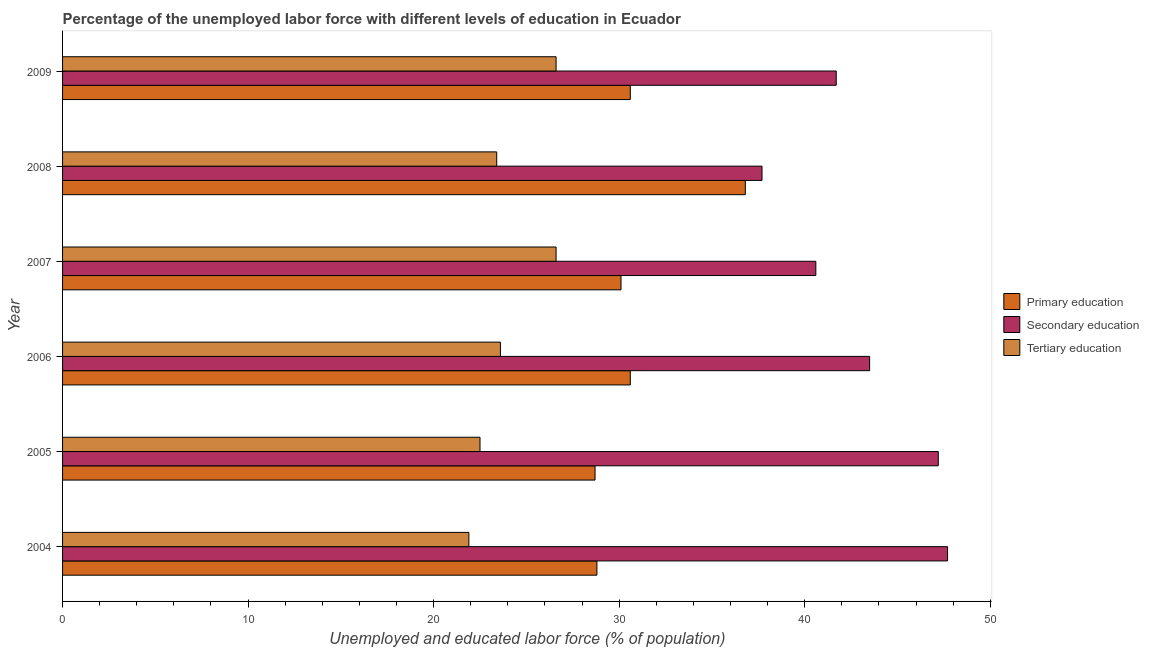Are the number of bars per tick equal to the number of legend labels?
Keep it short and to the point. Yes. Are the number of bars on each tick of the Y-axis equal?
Keep it short and to the point. Yes. How many bars are there on the 3rd tick from the bottom?
Provide a short and direct response. 3. In how many cases, is the number of bars for a given year not equal to the number of legend labels?
Give a very brief answer. 0. What is the percentage of labor force who received primary education in 2008?
Ensure brevity in your answer.  36.8. Across all years, what is the maximum percentage of labor force who received primary education?
Your answer should be very brief. 36.8. Across all years, what is the minimum percentage of labor force who received secondary education?
Offer a very short reply. 37.7. In which year was the percentage of labor force who received tertiary education maximum?
Keep it short and to the point. 2007. In which year was the percentage of labor force who received tertiary education minimum?
Keep it short and to the point. 2004. What is the total percentage of labor force who received secondary education in the graph?
Your response must be concise. 258.4. What is the difference between the percentage of labor force who received primary education in 2004 and the percentage of labor force who received tertiary education in 2008?
Provide a succinct answer. 5.4. What is the average percentage of labor force who received tertiary education per year?
Offer a very short reply. 24.1. In the year 2008, what is the difference between the percentage of labor force who received primary education and percentage of labor force who received secondary education?
Ensure brevity in your answer.  -0.9. In how many years, is the percentage of labor force who received tertiary education greater than 10 %?
Keep it short and to the point. 6. What is the ratio of the percentage of labor force who received tertiary education in 2006 to that in 2009?
Your response must be concise. 0.89. In how many years, is the percentage of labor force who received primary education greater than the average percentage of labor force who received primary education taken over all years?
Your answer should be compact. 1. What does the 1st bar from the top in 2008 represents?
Provide a succinct answer. Tertiary education. What does the 2nd bar from the bottom in 2009 represents?
Give a very brief answer. Secondary education. Is it the case that in every year, the sum of the percentage of labor force who received primary education and percentage of labor force who received secondary education is greater than the percentage of labor force who received tertiary education?
Provide a succinct answer. Yes. How many years are there in the graph?
Your answer should be very brief. 6. What is the difference between two consecutive major ticks on the X-axis?
Give a very brief answer. 10. Are the values on the major ticks of X-axis written in scientific E-notation?
Make the answer very short. No. Does the graph contain any zero values?
Offer a terse response. No. Does the graph contain grids?
Give a very brief answer. No. How many legend labels are there?
Provide a short and direct response. 3. What is the title of the graph?
Your response must be concise. Percentage of the unemployed labor force with different levels of education in Ecuador. What is the label or title of the X-axis?
Ensure brevity in your answer.  Unemployed and educated labor force (% of population). What is the Unemployed and educated labor force (% of population) of Primary education in 2004?
Give a very brief answer. 28.8. What is the Unemployed and educated labor force (% of population) of Secondary education in 2004?
Your response must be concise. 47.7. What is the Unemployed and educated labor force (% of population) of Tertiary education in 2004?
Give a very brief answer. 21.9. What is the Unemployed and educated labor force (% of population) of Primary education in 2005?
Provide a short and direct response. 28.7. What is the Unemployed and educated labor force (% of population) in Secondary education in 2005?
Your response must be concise. 47.2. What is the Unemployed and educated labor force (% of population) in Primary education in 2006?
Your answer should be very brief. 30.6. What is the Unemployed and educated labor force (% of population) of Secondary education in 2006?
Ensure brevity in your answer.  43.5. What is the Unemployed and educated labor force (% of population) of Tertiary education in 2006?
Give a very brief answer. 23.6. What is the Unemployed and educated labor force (% of population) of Primary education in 2007?
Provide a short and direct response. 30.1. What is the Unemployed and educated labor force (% of population) of Secondary education in 2007?
Offer a terse response. 40.6. What is the Unemployed and educated labor force (% of population) in Tertiary education in 2007?
Your answer should be compact. 26.6. What is the Unemployed and educated labor force (% of population) in Primary education in 2008?
Keep it short and to the point. 36.8. What is the Unemployed and educated labor force (% of population) in Secondary education in 2008?
Ensure brevity in your answer.  37.7. What is the Unemployed and educated labor force (% of population) of Tertiary education in 2008?
Provide a short and direct response. 23.4. What is the Unemployed and educated labor force (% of population) in Primary education in 2009?
Offer a terse response. 30.6. What is the Unemployed and educated labor force (% of population) in Secondary education in 2009?
Give a very brief answer. 41.7. What is the Unemployed and educated labor force (% of population) of Tertiary education in 2009?
Make the answer very short. 26.6. Across all years, what is the maximum Unemployed and educated labor force (% of population) in Primary education?
Provide a succinct answer. 36.8. Across all years, what is the maximum Unemployed and educated labor force (% of population) of Secondary education?
Your answer should be compact. 47.7. Across all years, what is the maximum Unemployed and educated labor force (% of population) in Tertiary education?
Ensure brevity in your answer.  26.6. Across all years, what is the minimum Unemployed and educated labor force (% of population) in Primary education?
Your answer should be compact. 28.7. Across all years, what is the minimum Unemployed and educated labor force (% of population) of Secondary education?
Your response must be concise. 37.7. Across all years, what is the minimum Unemployed and educated labor force (% of population) of Tertiary education?
Your answer should be compact. 21.9. What is the total Unemployed and educated labor force (% of population) in Primary education in the graph?
Your answer should be very brief. 185.6. What is the total Unemployed and educated labor force (% of population) of Secondary education in the graph?
Ensure brevity in your answer.  258.4. What is the total Unemployed and educated labor force (% of population) in Tertiary education in the graph?
Your response must be concise. 144.6. What is the difference between the Unemployed and educated labor force (% of population) in Primary education in 2004 and that in 2005?
Provide a succinct answer. 0.1. What is the difference between the Unemployed and educated labor force (% of population) in Secondary education in 2004 and that in 2005?
Provide a succinct answer. 0.5. What is the difference between the Unemployed and educated labor force (% of population) of Secondary education in 2004 and that in 2006?
Keep it short and to the point. 4.2. What is the difference between the Unemployed and educated labor force (% of population) in Tertiary education in 2004 and that in 2006?
Your response must be concise. -1.7. What is the difference between the Unemployed and educated labor force (% of population) of Secondary education in 2004 and that in 2007?
Provide a short and direct response. 7.1. What is the difference between the Unemployed and educated labor force (% of population) in Secondary education in 2004 and that in 2008?
Offer a very short reply. 10. What is the difference between the Unemployed and educated labor force (% of population) in Tertiary education in 2004 and that in 2008?
Ensure brevity in your answer.  -1.5. What is the difference between the Unemployed and educated labor force (% of population) of Primary education in 2004 and that in 2009?
Your answer should be very brief. -1.8. What is the difference between the Unemployed and educated labor force (% of population) of Secondary education in 2004 and that in 2009?
Make the answer very short. 6. What is the difference between the Unemployed and educated labor force (% of population) in Tertiary education in 2005 and that in 2006?
Make the answer very short. -1.1. What is the difference between the Unemployed and educated labor force (% of population) of Primary education in 2005 and that in 2007?
Your answer should be compact. -1.4. What is the difference between the Unemployed and educated labor force (% of population) of Primary education in 2005 and that in 2008?
Make the answer very short. -8.1. What is the difference between the Unemployed and educated labor force (% of population) in Secondary education in 2005 and that in 2008?
Keep it short and to the point. 9.5. What is the difference between the Unemployed and educated labor force (% of population) in Tertiary education in 2005 and that in 2008?
Keep it short and to the point. -0.9. What is the difference between the Unemployed and educated labor force (% of population) of Primary education in 2005 and that in 2009?
Provide a short and direct response. -1.9. What is the difference between the Unemployed and educated labor force (% of population) of Secondary education in 2005 and that in 2009?
Keep it short and to the point. 5.5. What is the difference between the Unemployed and educated labor force (% of population) of Tertiary education in 2005 and that in 2009?
Provide a succinct answer. -4.1. What is the difference between the Unemployed and educated labor force (% of population) in Primary education in 2006 and that in 2007?
Ensure brevity in your answer.  0.5. What is the difference between the Unemployed and educated labor force (% of population) of Primary education in 2006 and that in 2008?
Give a very brief answer. -6.2. What is the difference between the Unemployed and educated labor force (% of population) of Secondary education in 2006 and that in 2008?
Make the answer very short. 5.8. What is the difference between the Unemployed and educated labor force (% of population) in Tertiary education in 2007 and that in 2008?
Offer a very short reply. 3.2. What is the difference between the Unemployed and educated labor force (% of population) of Primary education in 2007 and that in 2009?
Your answer should be compact. -0.5. What is the difference between the Unemployed and educated labor force (% of population) in Secondary education in 2007 and that in 2009?
Offer a very short reply. -1.1. What is the difference between the Unemployed and educated labor force (% of population) of Tertiary education in 2007 and that in 2009?
Keep it short and to the point. 0. What is the difference between the Unemployed and educated labor force (% of population) of Primary education in 2008 and that in 2009?
Provide a succinct answer. 6.2. What is the difference between the Unemployed and educated labor force (% of population) in Primary education in 2004 and the Unemployed and educated labor force (% of population) in Secondary education in 2005?
Your response must be concise. -18.4. What is the difference between the Unemployed and educated labor force (% of population) in Secondary education in 2004 and the Unemployed and educated labor force (% of population) in Tertiary education in 2005?
Provide a short and direct response. 25.2. What is the difference between the Unemployed and educated labor force (% of population) of Primary education in 2004 and the Unemployed and educated labor force (% of population) of Secondary education in 2006?
Your response must be concise. -14.7. What is the difference between the Unemployed and educated labor force (% of population) in Secondary education in 2004 and the Unemployed and educated labor force (% of population) in Tertiary education in 2006?
Keep it short and to the point. 24.1. What is the difference between the Unemployed and educated labor force (% of population) of Primary education in 2004 and the Unemployed and educated labor force (% of population) of Tertiary education in 2007?
Your answer should be very brief. 2.2. What is the difference between the Unemployed and educated labor force (% of population) in Secondary education in 2004 and the Unemployed and educated labor force (% of population) in Tertiary education in 2007?
Give a very brief answer. 21.1. What is the difference between the Unemployed and educated labor force (% of population) of Primary education in 2004 and the Unemployed and educated labor force (% of population) of Secondary education in 2008?
Your answer should be very brief. -8.9. What is the difference between the Unemployed and educated labor force (% of population) in Secondary education in 2004 and the Unemployed and educated labor force (% of population) in Tertiary education in 2008?
Provide a succinct answer. 24.3. What is the difference between the Unemployed and educated labor force (% of population) of Secondary education in 2004 and the Unemployed and educated labor force (% of population) of Tertiary education in 2009?
Provide a succinct answer. 21.1. What is the difference between the Unemployed and educated labor force (% of population) of Primary education in 2005 and the Unemployed and educated labor force (% of population) of Secondary education in 2006?
Provide a succinct answer. -14.8. What is the difference between the Unemployed and educated labor force (% of population) of Primary education in 2005 and the Unemployed and educated labor force (% of population) of Tertiary education in 2006?
Give a very brief answer. 5.1. What is the difference between the Unemployed and educated labor force (% of population) of Secondary education in 2005 and the Unemployed and educated labor force (% of population) of Tertiary education in 2006?
Give a very brief answer. 23.6. What is the difference between the Unemployed and educated labor force (% of population) of Secondary education in 2005 and the Unemployed and educated labor force (% of population) of Tertiary education in 2007?
Your answer should be compact. 20.6. What is the difference between the Unemployed and educated labor force (% of population) of Secondary education in 2005 and the Unemployed and educated labor force (% of population) of Tertiary education in 2008?
Provide a succinct answer. 23.8. What is the difference between the Unemployed and educated labor force (% of population) in Primary education in 2005 and the Unemployed and educated labor force (% of population) in Secondary education in 2009?
Make the answer very short. -13. What is the difference between the Unemployed and educated labor force (% of population) of Primary education in 2005 and the Unemployed and educated labor force (% of population) of Tertiary education in 2009?
Your answer should be very brief. 2.1. What is the difference between the Unemployed and educated labor force (% of population) of Secondary education in 2005 and the Unemployed and educated labor force (% of population) of Tertiary education in 2009?
Your response must be concise. 20.6. What is the difference between the Unemployed and educated labor force (% of population) of Primary education in 2006 and the Unemployed and educated labor force (% of population) of Secondary education in 2007?
Your response must be concise. -10. What is the difference between the Unemployed and educated labor force (% of population) in Primary education in 2006 and the Unemployed and educated labor force (% of population) in Secondary education in 2008?
Your answer should be compact. -7.1. What is the difference between the Unemployed and educated labor force (% of population) in Primary education in 2006 and the Unemployed and educated labor force (% of population) in Tertiary education in 2008?
Your answer should be compact. 7.2. What is the difference between the Unemployed and educated labor force (% of population) of Secondary education in 2006 and the Unemployed and educated labor force (% of population) of Tertiary education in 2008?
Give a very brief answer. 20.1. What is the difference between the Unemployed and educated labor force (% of population) in Primary education in 2006 and the Unemployed and educated labor force (% of population) in Secondary education in 2009?
Offer a terse response. -11.1. What is the difference between the Unemployed and educated labor force (% of population) of Primary education in 2006 and the Unemployed and educated labor force (% of population) of Tertiary education in 2009?
Make the answer very short. 4. What is the difference between the Unemployed and educated labor force (% of population) in Secondary education in 2006 and the Unemployed and educated labor force (% of population) in Tertiary education in 2009?
Give a very brief answer. 16.9. What is the difference between the Unemployed and educated labor force (% of population) of Primary education in 2007 and the Unemployed and educated labor force (% of population) of Secondary education in 2008?
Keep it short and to the point. -7.6. What is the difference between the Unemployed and educated labor force (% of population) in Secondary education in 2007 and the Unemployed and educated labor force (% of population) in Tertiary education in 2008?
Keep it short and to the point. 17.2. What is the difference between the Unemployed and educated labor force (% of population) in Primary education in 2007 and the Unemployed and educated labor force (% of population) in Secondary education in 2009?
Offer a very short reply. -11.6. What is the difference between the Unemployed and educated labor force (% of population) in Primary education in 2007 and the Unemployed and educated labor force (% of population) in Tertiary education in 2009?
Your answer should be compact. 3.5. What is the difference between the Unemployed and educated labor force (% of population) in Primary education in 2008 and the Unemployed and educated labor force (% of population) in Tertiary education in 2009?
Ensure brevity in your answer.  10.2. What is the average Unemployed and educated labor force (% of population) in Primary education per year?
Your answer should be compact. 30.93. What is the average Unemployed and educated labor force (% of population) of Secondary education per year?
Ensure brevity in your answer.  43.07. What is the average Unemployed and educated labor force (% of population) in Tertiary education per year?
Keep it short and to the point. 24.1. In the year 2004, what is the difference between the Unemployed and educated labor force (% of population) in Primary education and Unemployed and educated labor force (% of population) in Secondary education?
Keep it short and to the point. -18.9. In the year 2004, what is the difference between the Unemployed and educated labor force (% of population) in Primary education and Unemployed and educated labor force (% of population) in Tertiary education?
Keep it short and to the point. 6.9. In the year 2004, what is the difference between the Unemployed and educated labor force (% of population) in Secondary education and Unemployed and educated labor force (% of population) in Tertiary education?
Your answer should be very brief. 25.8. In the year 2005, what is the difference between the Unemployed and educated labor force (% of population) of Primary education and Unemployed and educated labor force (% of population) of Secondary education?
Offer a very short reply. -18.5. In the year 2005, what is the difference between the Unemployed and educated labor force (% of population) of Secondary education and Unemployed and educated labor force (% of population) of Tertiary education?
Keep it short and to the point. 24.7. In the year 2006, what is the difference between the Unemployed and educated labor force (% of population) of Primary education and Unemployed and educated labor force (% of population) of Tertiary education?
Provide a succinct answer. 7. In the year 2006, what is the difference between the Unemployed and educated labor force (% of population) of Secondary education and Unemployed and educated labor force (% of population) of Tertiary education?
Give a very brief answer. 19.9. In the year 2009, what is the difference between the Unemployed and educated labor force (% of population) of Primary education and Unemployed and educated labor force (% of population) of Tertiary education?
Ensure brevity in your answer.  4. What is the ratio of the Unemployed and educated labor force (% of population) of Secondary education in 2004 to that in 2005?
Ensure brevity in your answer.  1.01. What is the ratio of the Unemployed and educated labor force (% of population) of Tertiary education in 2004 to that in 2005?
Offer a terse response. 0.97. What is the ratio of the Unemployed and educated labor force (% of population) of Primary education in 2004 to that in 2006?
Your answer should be very brief. 0.94. What is the ratio of the Unemployed and educated labor force (% of population) of Secondary education in 2004 to that in 2006?
Your answer should be compact. 1.1. What is the ratio of the Unemployed and educated labor force (% of population) of Tertiary education in 2004 to that in 2006?
Provide a short and direct response. 0.93. What is the ratio of the Unemployed and educated labor force (% of population) in Primary education in 2004 to that in 2007?
Provide a short and direct response. 0.96. What is the ratio of the Unemployed and educated labor force (% of population) in Secondary education in 2004 to that in 2007?
Your response must be concise. 1.17. What is the ratio of the Unemployed and educated labor force (% of population) in Tertiary education in 2004 to that in 2007?
Offer a terse response. 0.82. What is the ratio of the Unemployed and educated labor force (% of population) of Primary education in 2004 to that in 2008?
Provide a succinct answer. 0.78. What is the ratio of the Unemployed and educated labor force (% of population) of Secondary education in 2004 to that in 2008?
Provide a succinct answer. 1.27. What is the ratio of the Unemployed and educated labor force (% of population) of Tertiary education in 2004 to that in 2008?
Make the answer very short. 0.94. What is the ratio of the Unemployed and educated labor force (% of population) in Secondary education in 2004 to that in 2009?
Offer a very short reply. 1.14. What is the ratio of the Unemployed and educated labor force (% of population) in Tertiary education in 2004 to that in 2009?
Provide a succinct answer. 0.82. What is the ratio of the Unemployed and educated labor force (% of population) of Primary education in 2005 to that in 2006?
Provide a succinct answer. 0.94. What is the ratio of the Unemployed and educated labor force (% of population) in Secondary education in 2005 to that in 2006?
Keep it short and to the point. 1.09. What is the ratio of the Unemployed and educated labor force (% of population) of Tertiary education in 2005 to that in 2006?
Ensure brevity in your answer.  0.95. What is the ratio of the Unemployed and educated labor force (% of population) of Primary education in 2005 to that in 2007?
Offer a terse response. 0.95. What is the ratio of the Unemployed and educated labor force (% of population) in Secondary education in 2005 to that in 2007?
Provide a short and direct response. 1.16. What is the ratio of the Unemployed and educated labor force (% of population) in Tertiary education in 2005 to that in 2007?
Your response must be concise. 0.85. What is the ratio of the Unemployed and educated labor force (% of population) of Primary education in 2005 to that in 2008?
Offer a terse response. 0.78. What is the ratio of the Unemployed and educated labor force (% of population) of Secondary education in 2005 to that in 2008?
Your answer should be very brief. 1.25. What is the ratio of the Unemployed and educated labor force (% of population) of Tertiary education in 2005 to that in 2008?
Provide a short and direct response. 0.96. What is the ratio of the Unemployed and educated labor force (% of population) in Primary education in 2005 to that in 2009?
Offer a very short reply. 0.94. What is the ratio of the Unemployed and educated labor force (% of population) of Secondary education in 2005 to that in 2009?
Provide a succinct answer. 1.13. What is the ratio of the Unemployed and educated labor force (% of population) of Tertiary education in 2005 to that in 2009?
Offer a very short reply. 0.85. What is the ratio of the Unemployed and educated labor force (% of population) in Primary education in 2006 to that in 2007?
Keep it short and to the point. 1.02. What is the ratio of the Unemployed and educated labor force (% of population) in Secondary education in 2006 to that in 2007?
Give a very brief answer. 1.07. What is the ratio of the Unemployed and educated labor force (% of population) of Tertiary education in 2006 to that in 2007?
Provide a succinct answer. 0.89. What is the ratio of the Unemployed and educated labor force (% of population) in Primary education in 2006 to that in 2008?
Make the answer very short. 0.83. What is the ratio of the Unemployed and educated labor force (% of population) of Secondary education in 2006 to that in 2008?
Offer a very short reply. 1.15. What is the ratio of the Unemployed and educated labor force (% of population) of Tertiary education in 2006 to that in 2008?
Keep it short and to the point. 1.01. What is the ratio of the Unemployed and educated labor force (% of population) of Primary education in 2006 to that in 2009?
Give a very brief answer. 1. What is the ratio of the Unemployed and educated labor force (% of population) in Secondary education in 2006 to that in 2009?
Your response must be concise. 1.04. What is the ratio of the Unemployed and educated labor force (% of population) in Tertiary education in 2006 to that in 2009?
Give a very brief answer. 0.89. What is the ratio of the Unemployed and educated labor force (% of population) in Primary education in 2007 to that in 2008?
Keep it short and to the point. 0.82. What is the ratio of the Unemployed and educated labor force (% of population) in Tertiary education in 2007 to that in 2008?
Give a very brief answer. 1.14. What is the ratio of the Unemployed and educated labor force (% of population) of Primary education in 2007 to that in 2009?
Make the answer very short. 0.98. What is the ratio of the Unemployed and educated labor force (% of population) of Secondary education in 2007 to that in 2009?
Provide a succinct answer. 0.97. What is the ratio of the Unemployed and educated labor force (% of population) in Primary education in 2008 to that in 2009?
Provide a succinct answer. 1.2. What is the ratio of the Unemployed and educated labor force (% of population) in Secondary education in 2008 to that in 2009?
Offer a very short reply. 0.9. What is the ratio of the Unemployed and educated labor force (% of population) in Tertiary education in 2008 to that in 2009?
Provide a succinct answer. 0.88. What is the difference between the highest and the second highest Unemployed and educated labor force (% of population) in Primary education?
Offer a very short reply. 6.2. What is the difference between the highest and the second highest Unemployed and educated labor force (% of population) in Tertiary education?
Ensure brevity in your answer.  0. What is the difference between the highest and the lowest Unemployed and educated labor force (% of population) of Primary education?
Your response must be concise. 8.1. 